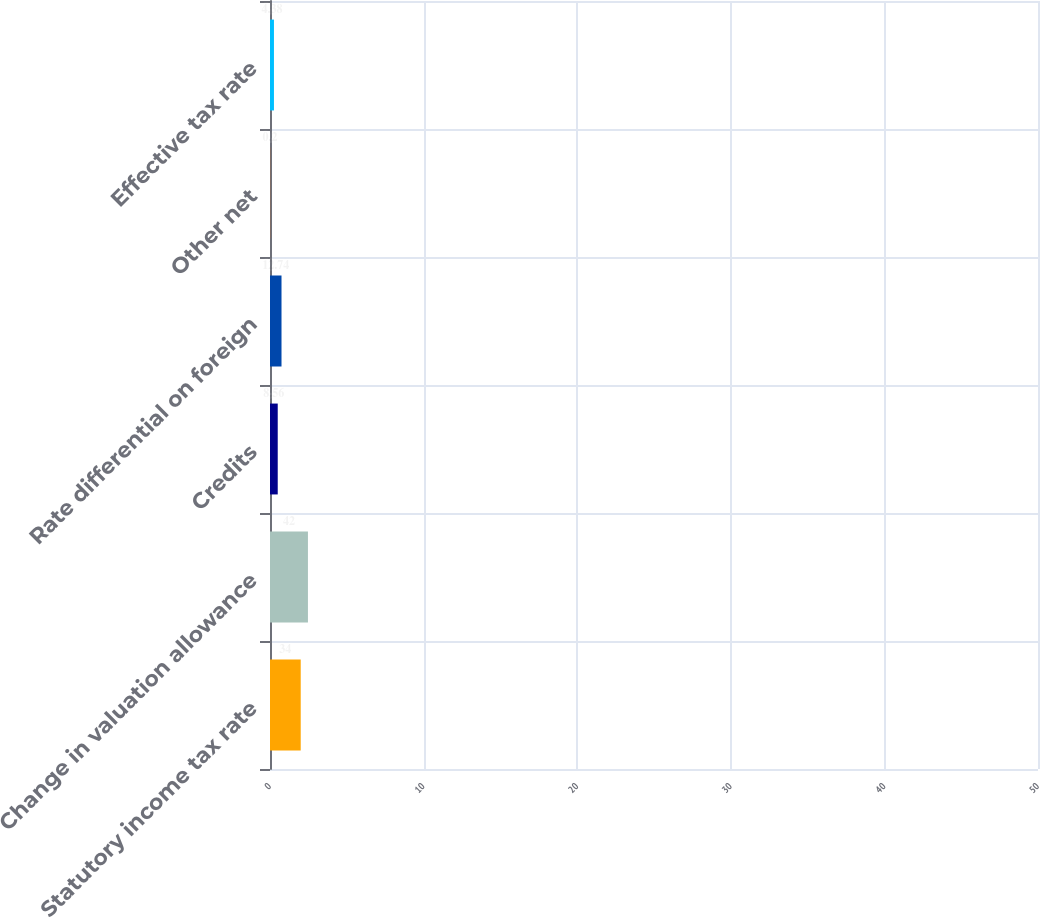<chart> <loc_0><loc_0><loc_500><loc_500><bar_chart><fcel>Statutory income tax rate<fcel>Change in valuation allowance<fcel>Credits<fcel>Rate differential on foreign<fcel>Other net<fcel>Effective tax rate<nl><fcel>34<fcel>42<fcel>8.56<fcel>12.74<fcel>0.2<fcel>4.38<nl></chart> 